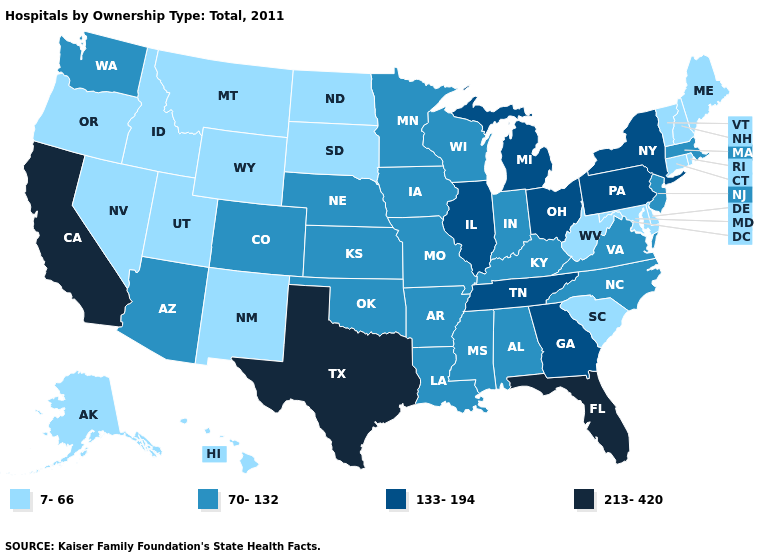What is the highest value in states that border Massachusetts?
Give a very brief answer. 133-194. What is the value of Ohio?
Be succinct. 133-194. Does Washington have the lowest value in the USA?
Give a very brief answer. No. What is the lowest value in the MidWest?
Answer briefly. 7-66. What is the highest value in the MidWest ?
Be succinct. 133-194. Among the states that border Pennsylvania , which have the lowest value?
Keep it brief. Delaware, Maryland, West Virginia. Name the states that have a value in the range 70-132?
Give a very brief answer. Alabama, Arizona, Arkansas, Colorado, Indiana, Iowa, Kansas, Kentucky, Louisiana, Massachusetts, Minnesota, Mississippi, Missouri, Nebraska, New Jersey, North Carolina, Oklahoma, Virginia, Washington, Wisconsin. Among the states that border West Virginia , does Ohio have the highest value?
Quick response, please. Yes. Does Wisconsin have the highest value in the USA?
Be succinct. No. Does Texas have the highest value in the USA?
Keep it brief. Yes. What is the value of Oregon?
Be succinct. 7-66. Does Colorado have the lowest value in the West?
Keep it brief. No. Which states have the highest value in the USA?
Keep it brief. California, Florida, Texas. Name the states that have a value in the range 70-132?
Be succinct. Alabama, Arizona, Arkansas, Colorado, Indiana, Iowa, Kansas, Kentucky, Louisiana, Massachusetts, Minnesota, Mississippi, Missouri, Nebraska, New Jersey, North Carolina, Oklahoma, Virginia, Washington, Wisconsin. Which states hav the highest value in the MidWest?
Quick response, please. Illinois, Michigan, Ohio. 